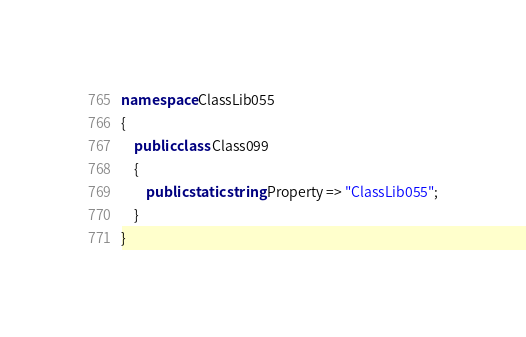Convert code to text. <code><loc_0><loc_0><loc_500><loc_500><_C#_>namespace ClassLib055
{
    public class Class099
    {
        public static string Property => "ClassLib055";
    }
}
</code> 